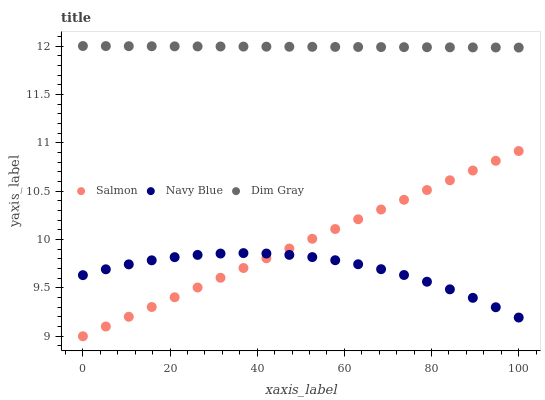Does Navy Blue have the minimum area under the curve?
Answer yes or no. Yes. Does Dim Gray have the maximum area under the curve?
Answer yes or no. Yes. Does Salmon have the minimum area under the curve?
Answer yes or no. No. Does Salmon have the maximum area under the curve?
Answer yes or no. No. Is Salmon the smoothest?
Answer yes or no. Yes. Is Navy Blue the roughest?
Answer yes or no. Yes. Is Dim Gray the smoothest?
Answer yes or no. No. Is Dim Gray the roughest?
Answer yes or no. No. Does Salmon have the lowest value?
Answer yes or no. Yes. Does Dim Gray have the lowest value?
Answer yes or no. No. Does Dim Gray have the highest value?
Answer yes or no. Yes. Does Salmon have the highest value?
Answer yes or no. No. Is Salmon less than Dim Gray?
Answer yes or no. Yes. Is Dim Gray greater than Navy Blue?
Answer yes or no. Yes. Does Navy Blue intersect Salmon?
Answer yes or no. Yes. Is Navy Blue less than Salmon?
Answer yes or no. No. Is Navy Blue greater than Salmon?
Answer yes or no. No. Does Salmon intersect Dim Gray?
Answer yes or no. No. 